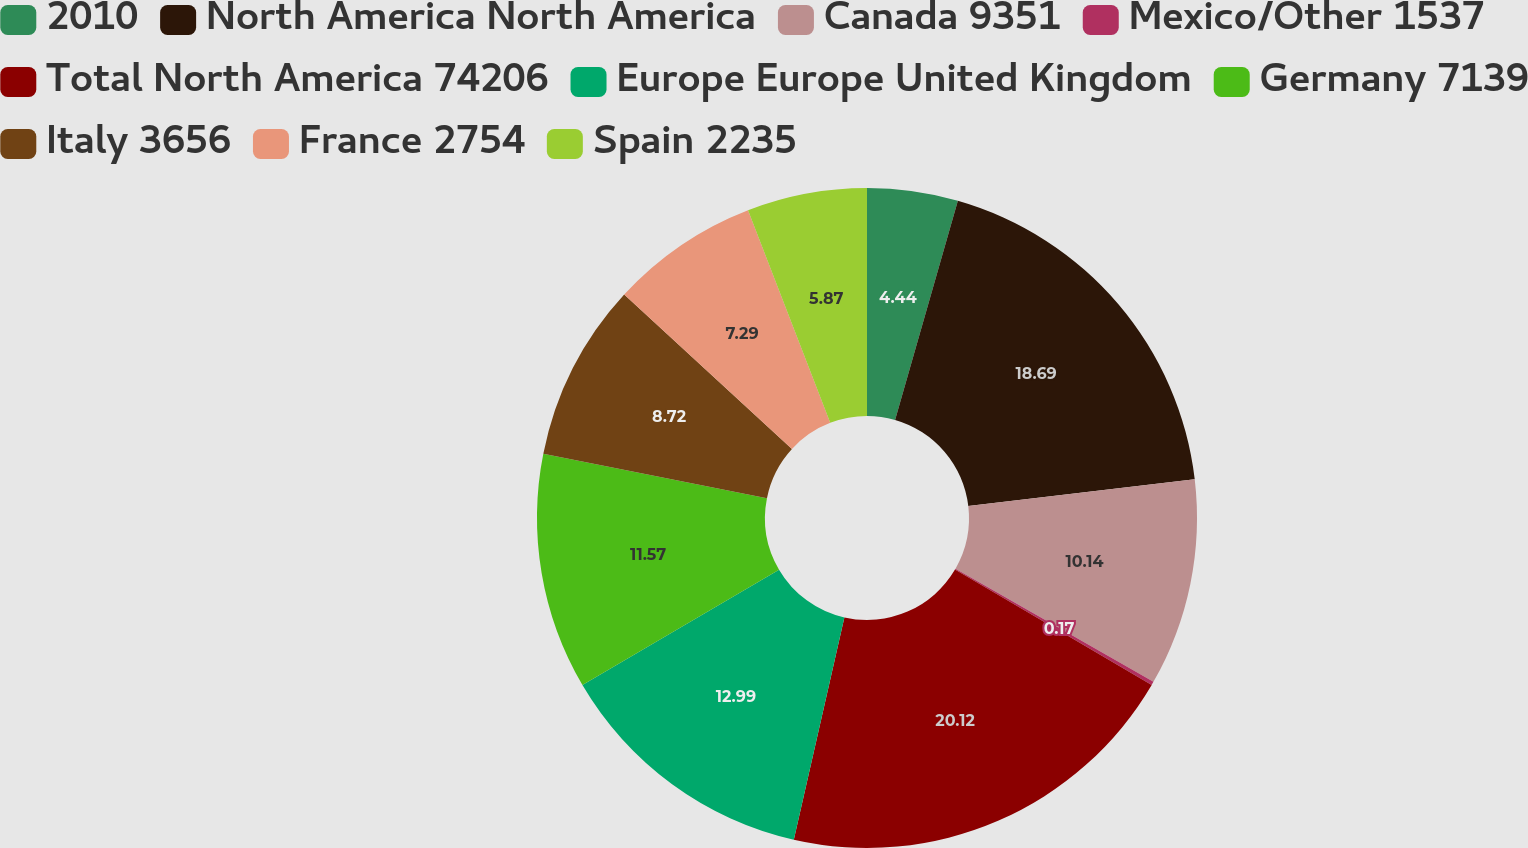Convert chart to OTSL. <chart><loc_0><loc_0><loc_500><loc_500><pie_chart><fcel>2010<fcel>North America North America<fcel>Canada 9351<fcel>Mexico/Other 1537<fcel>Total North America 74206<fcel>Europe Europe United Kingdom<fcel>Germany 7139<fcel>Italy 3656<fcel>France 2754<fcel>Spain 2235<nl><fcel>4.44%<fcel>18.69%<fcel>10.14%<fcel>0.17%<fcel>20.12%<fcel>12.99%<fcel>11.57%<fcel>8.72%<fcel>7.29%<fcel>5.87%<nl></chart> 